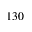<formula> <loc_0><loc_0><loc_500><loc_500>1 3 0</formula> 